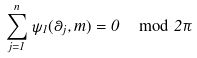<formula> <loc_0><loc_0><loc_500><loc_500>\sum _ { j = 1 } ^ { n } \psi _ { 1 } ( \theta _ { j } , m ) = 0 \, \mod 2 \pi</formula> 